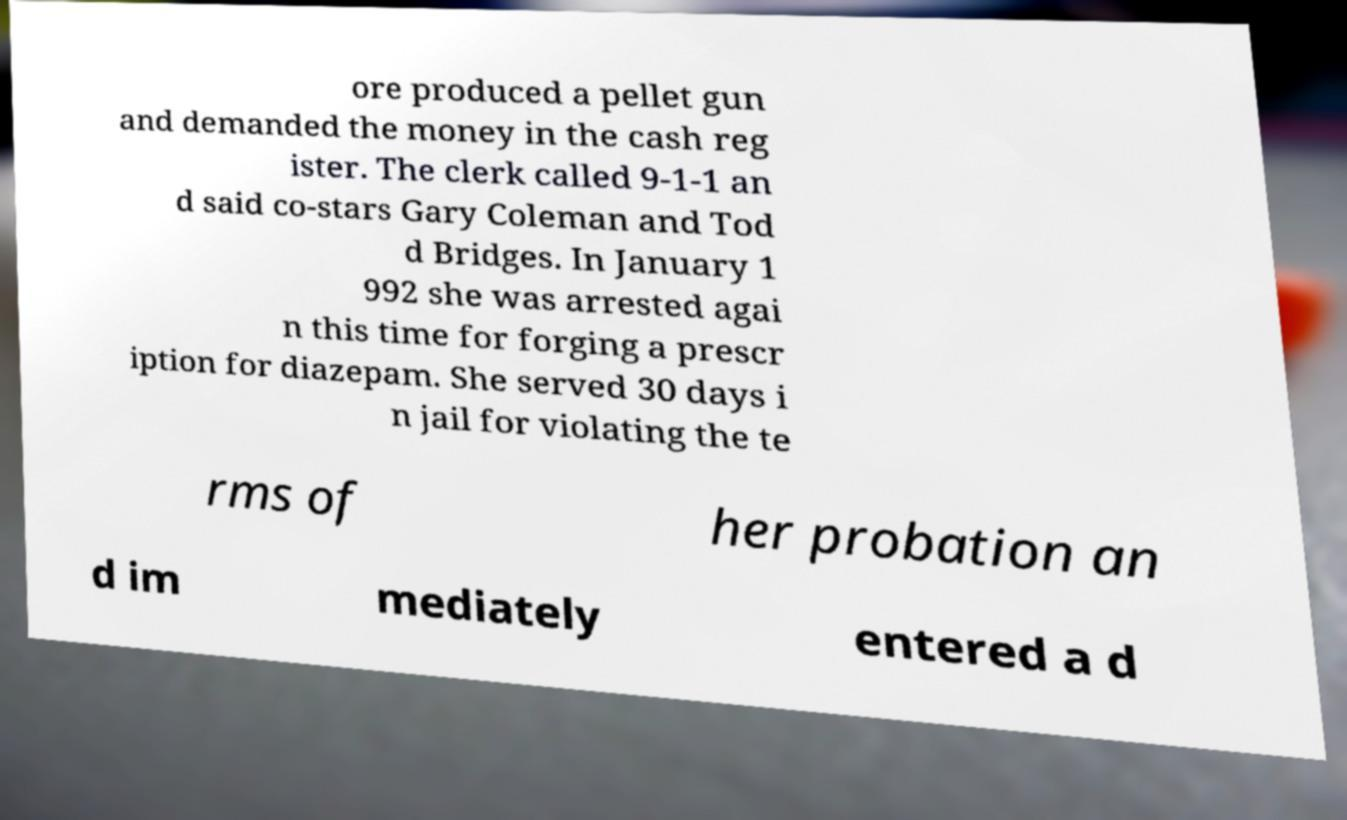Can you accurately transcribe the text from the provided image for me? ore produced a pellet gun and demanded the money in the cash reg ister. The clerk called 9-1-1 an d said co-stars Gary Coleman and Tod d Bridges. In January 1 992 she was arrested agai n this time for forging a prescr iption for diazepam. She served 30 days i n jail for violating the te rms of her probation an d im mediately entered a d 